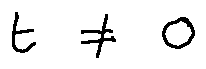Convert formula to latex. <formula><loc_0><loc_0><loc_500><loc_500>t \neq 0</formula> 